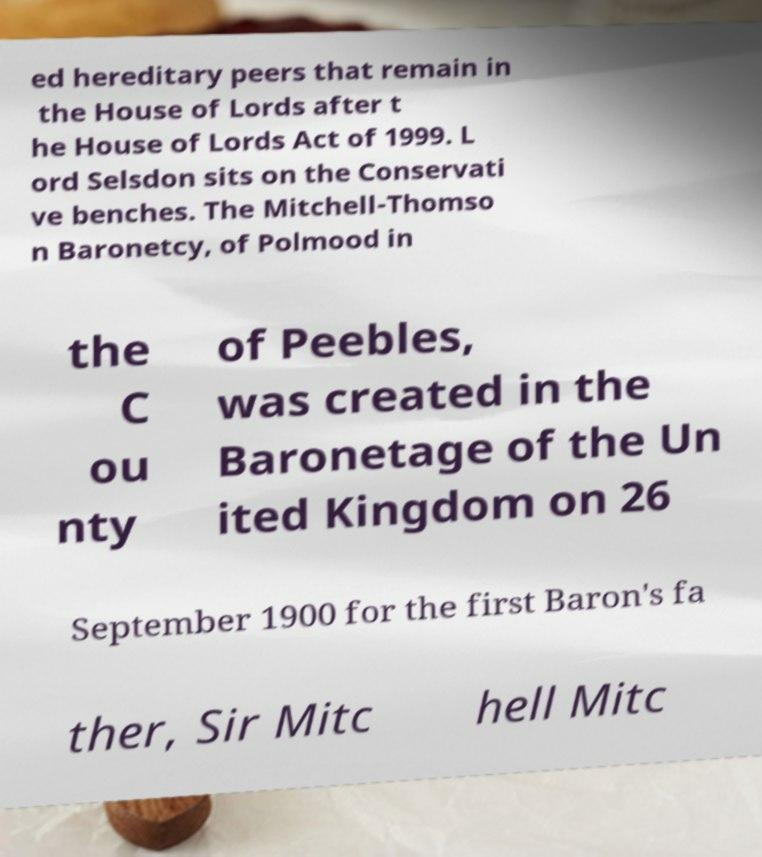There's text embedded in this image that I need extracted. Can you transcribe it verbatim? ed hereditary peers that remain in the House of Lords after t he House of Lords Act of 1999. L ord Selsdon sits on the Conservati ve benches. The Mitchell-Thomso n Baronetcy, of Polmood in the C ou nty of Peebles, was created in the Baronetage of the Un ited Kingdom on 26 September 1900 for the first Baron's fa ther, Sir Mitc hell Mitc 